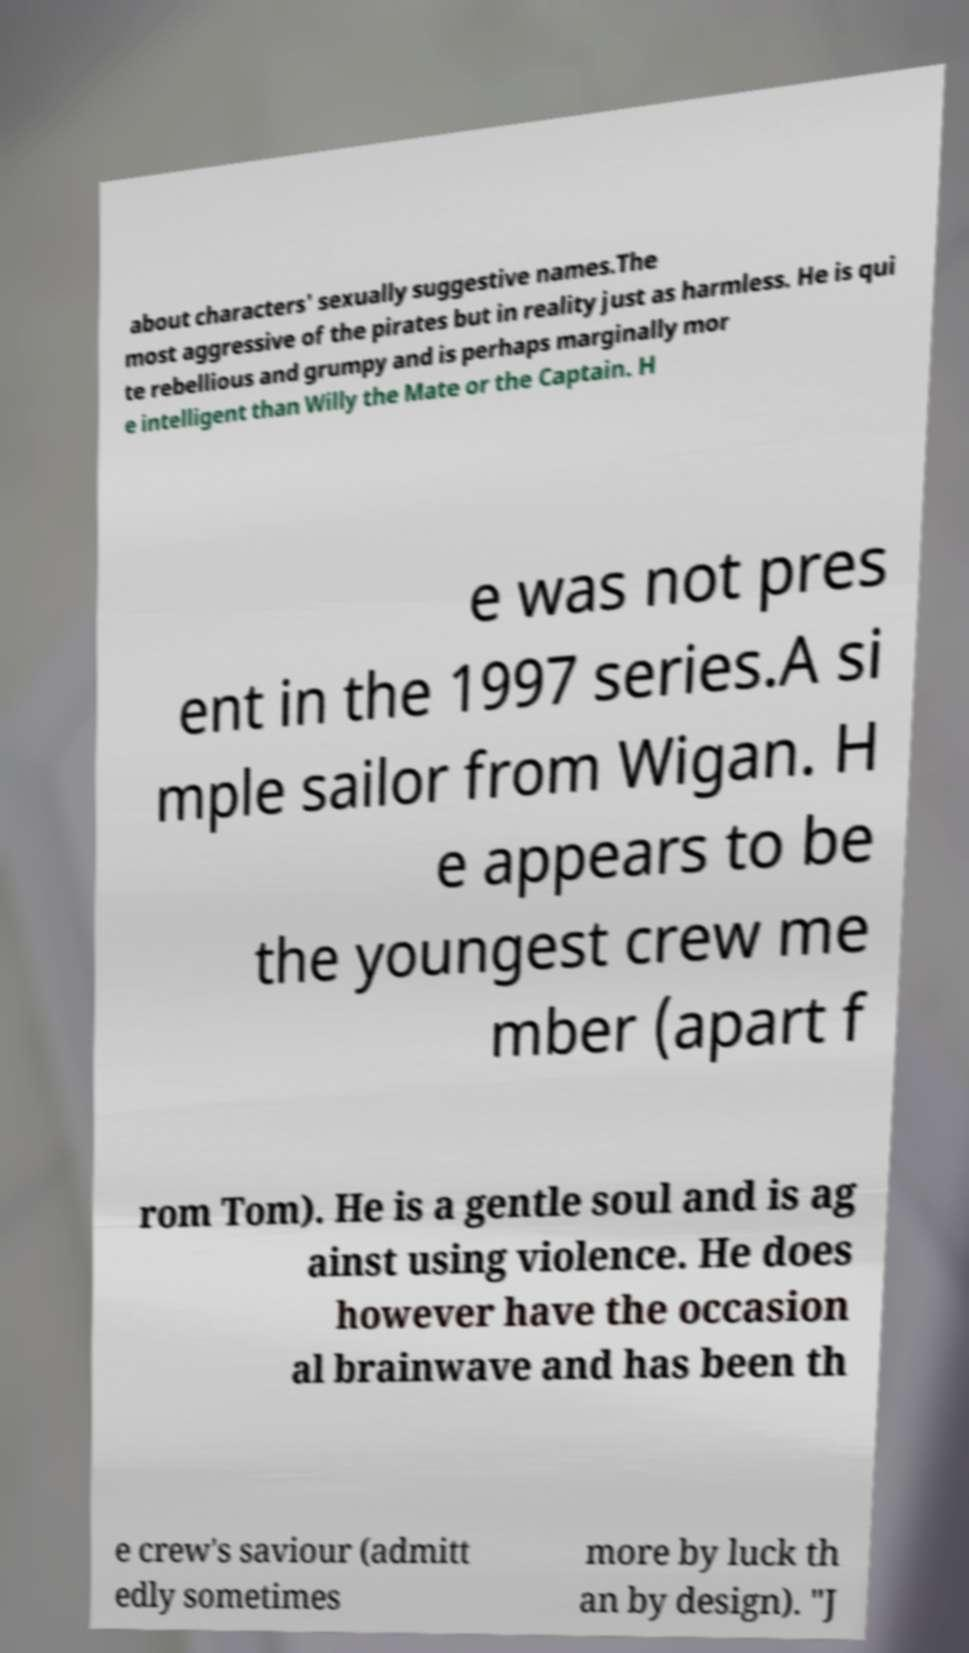Please read and relay the text visible in this image. What does it say? about characters' sexually suggestive names.The most aggressive of the pirates but in reality just as harmless. He is qui te rebellious and grumpy and is perhaps marginally mor e intelligent than Willy the Mate or the Captain. H e was not pres ent in the 1997 series.A si mple sailor from Wigan. H e appears to be the youngest crew me mber (apart f rom Tom). He is a gentle soul and is ag ainst using violence. He does however have the occasion al brainwave and has been th e crew's saviour (admitt edly sometimes more by luck th an by design). "J 